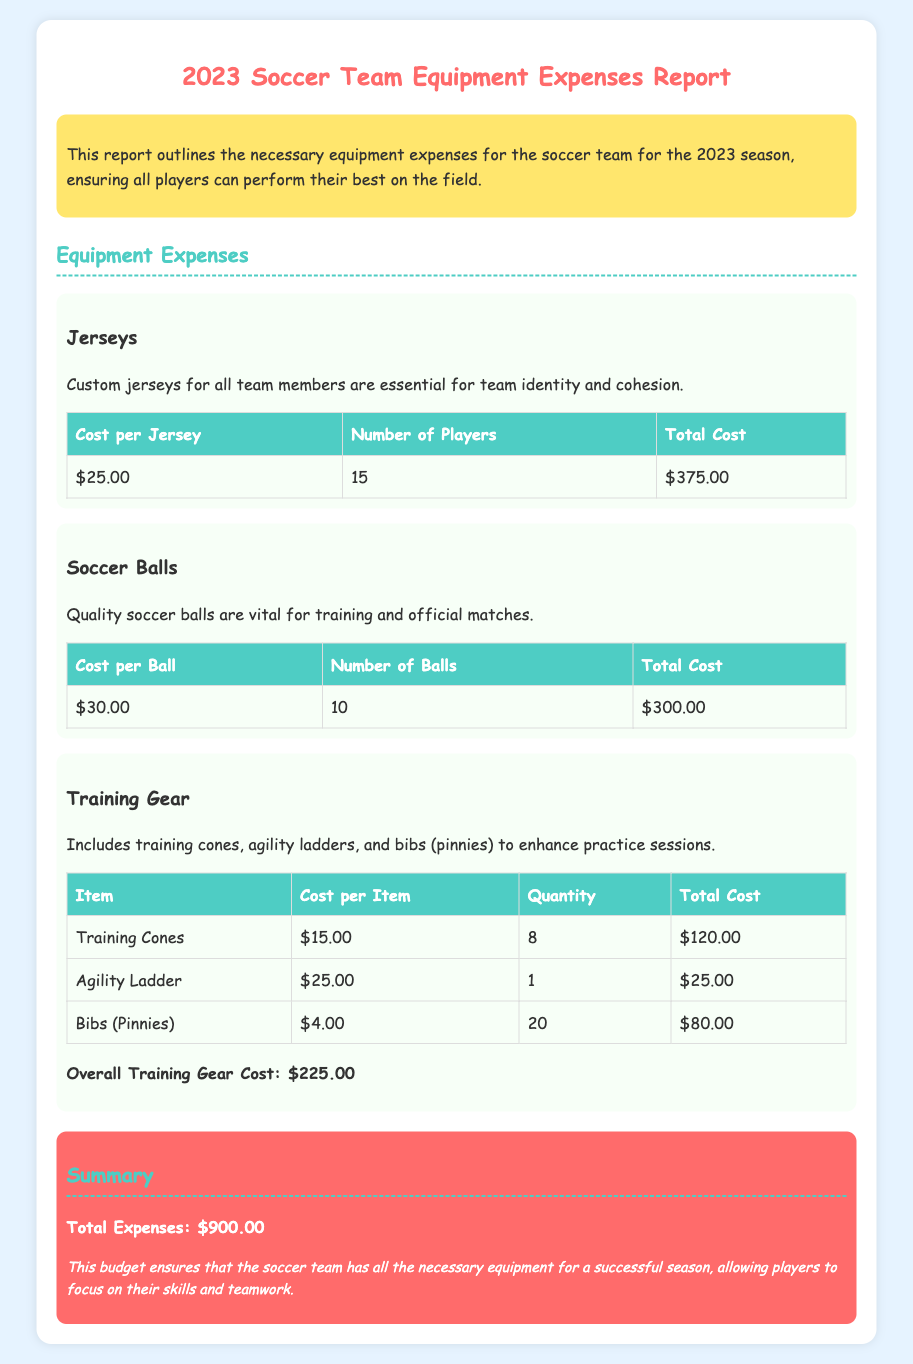what is the cost per jersey? The cost per jersey is listed in the equipment expenses section for jerseys.
Answer: $25.00 how many players are there on the team? The number of players is indicated in the jerseys section.
Answer: 15 what is the total cost for soccer balls? The total cost for soccer balls can be found in the soccer balls section.
Answer: $300.00 how much did the training cones cost? The cost for training cones can be retrieved from the training gear section.
Answer: $120.00 what is the overall training gear cost? The overall training gear cost is summarized after the table for training gear items.
Answer: $225.00 what is the total expenses for the season? The total expenses is listed in the summary section.
Answer: $900.00 how many soccer balls were purchased? The number of soccer balls is stated in the soccer balls section.
Answer: 10 what is the cost of one agility ladder? The cost of an agility ladder can be found in the training gear table.
Answer: $25.00 what type of financial document is this? The document outlines the costs associated with team equipment.
Answer: financial report 